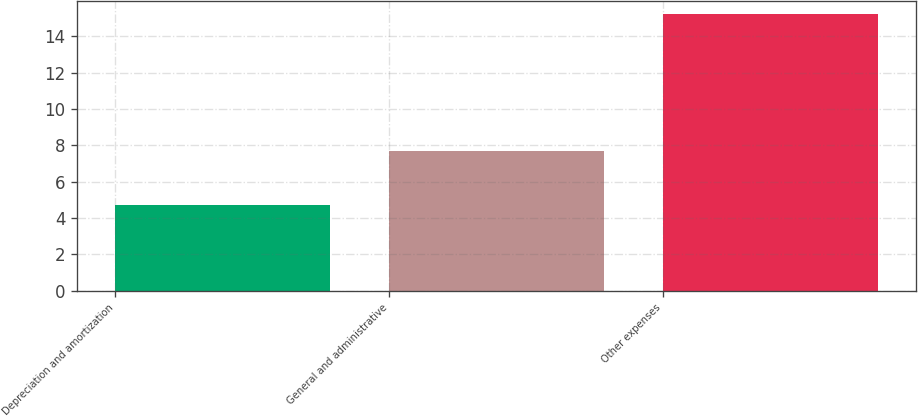<chart> <loc_0><loc_0><loc_500><loc_500><bar_chart><fcel>Depreciation and amortization<fcel>General and administrative<fcel>Other expenses<nl><fcel>4.7<fcel>7.7<fcel>15.2<nl></chart> 